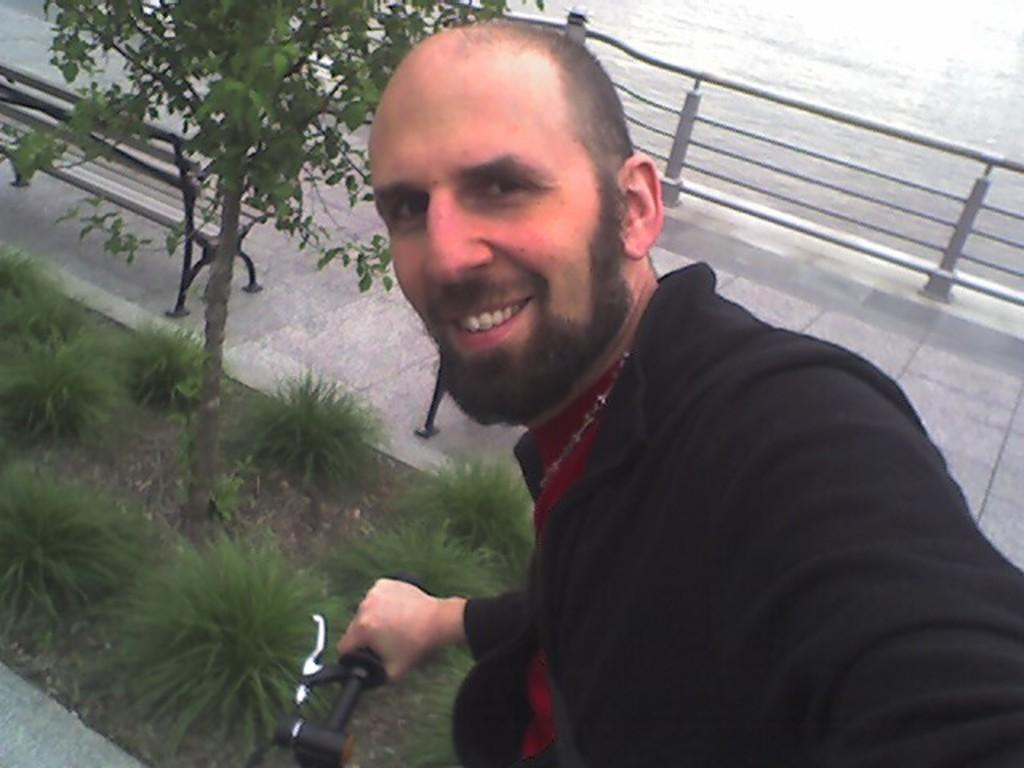What is one of the main features of the image? There is a road in the image. What other objects or structures can be seen in the image? There is a fence, a plant, a bench, and grass visible in the image. Can you describe the man in the image? The man in the image is holding a bicycle. What type of alarm is the man setting up on the bed in the image? There is no bed or alarm present in the image. What is the man using the hammer for in the image? There is no hammer present in the image. 